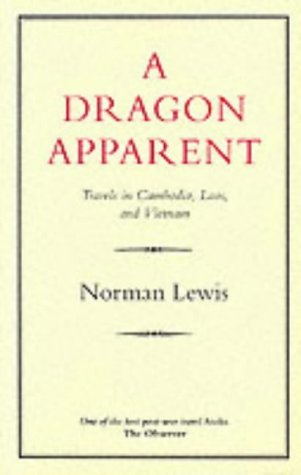Is this book related to Crafts, Hobbies & Home? No, this book is not related to Crafts, Hobbies & Home. It focuses primarily on travel and the exploration of various cultures in Southeast Asia. 